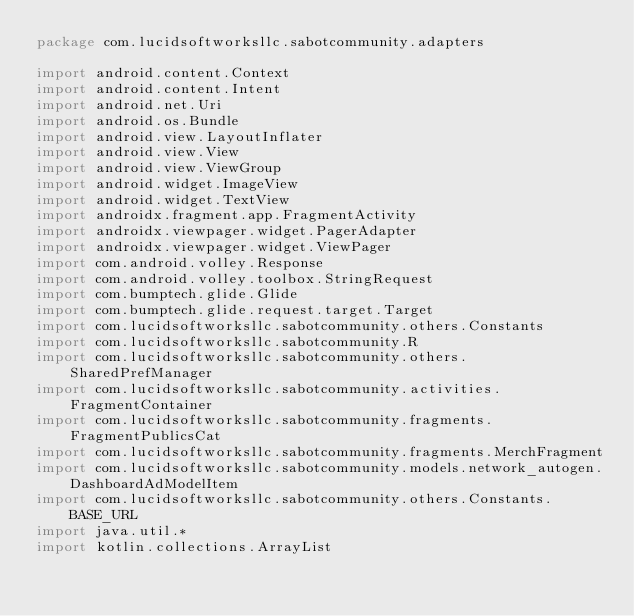Convert code to text. <code><loc_0><loc_0><loc_500><loc_500><_Kotlin_>package com.lucidsoftworksllc.sabotcommunity.adapters

import android.content.Context
import android.content.Intent
import android.net.Uri
import android.os.Bundle
import android.view.LayoutInflater
import android.view.View
import android.view.ViewGroup
import android.widget.ImageView
import android.widget.TextView
import androidx.fragment.app.FragmentActivity
import androidx.viewpager.widget.PagerAdapter
import androidx.viewpager.widget.ViewPager
import com.android.volley.Response
import com.android.volley.toolbox.StringRequest
import com.bumptech.glide.Glide
import com.bumptech.glide.request.target.Target
import com.lucidsoftworksllc.sabotcommunity.others.Constants
import com.lucidsoftworksllc.sabotcommunity.R
import com.lucidsoftworksllc.sabotcommunity.others.SharedPrefManager
import com.lucidsoftworksllc.sabotcommunity.activities.FragmentContainer
import com.lucidsoftworksllc.sabotcommunity.fragments.FragmentPublicsCat
import com.lucidsoftworksllc.sabotcommunity.fragments.MerchFragment
import com.lucidsoftworksllc.sabotcommunity.models.network_autogen.DashboardAdModelItem
import com.lucidsoftworksllc.sabotcommunity.others.Constants.BASE_URL
import java.util.*
import kotlin.collections.ArrayList
</code> 